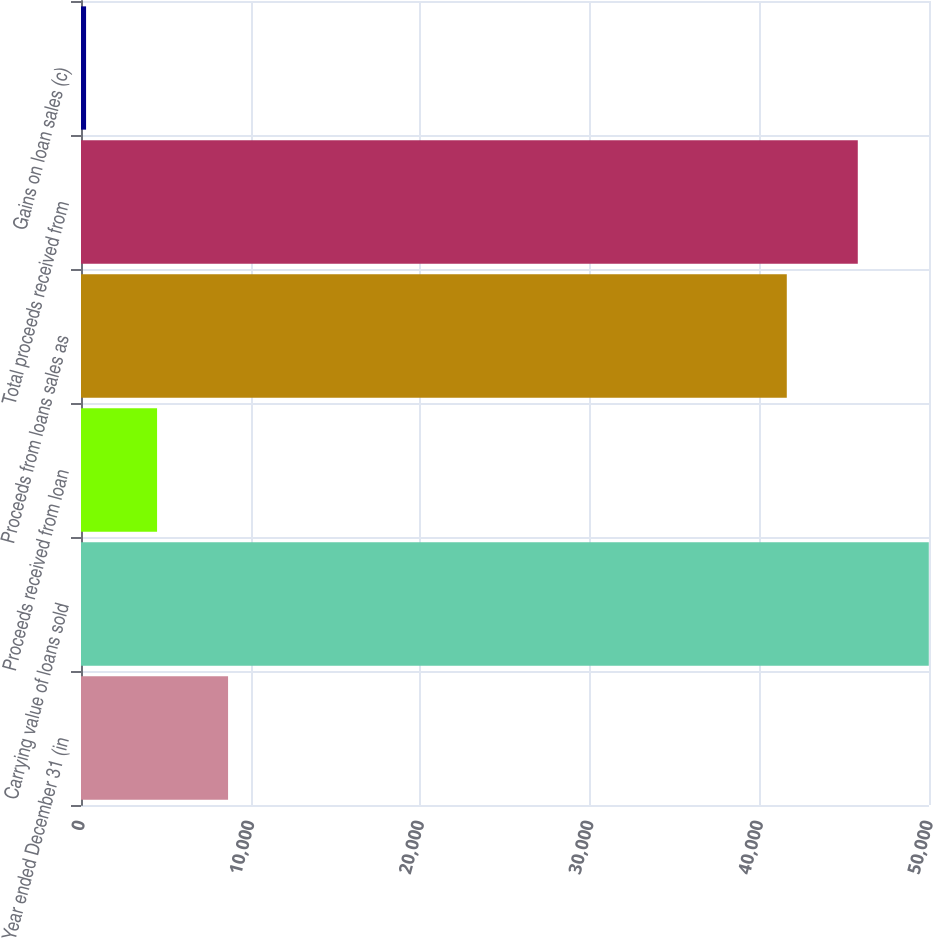Convert chart. <chart><loc_0><loc_0><loc_500><loc_500><bar_chart><fcel>Year ended December 31 (in<fcel>Carrying value of loans sold<fcel>Proceeds received from loan<fcel>Proceeds from loans sales as<fcel>Total proceeds received from<fcel>Gains on loan sales (c)<nl><fcel>8671.4<fcel>49987.4<fcel>4485.2<fcel>41615<fcel>45801.2<fcel>299<nl></chart> 